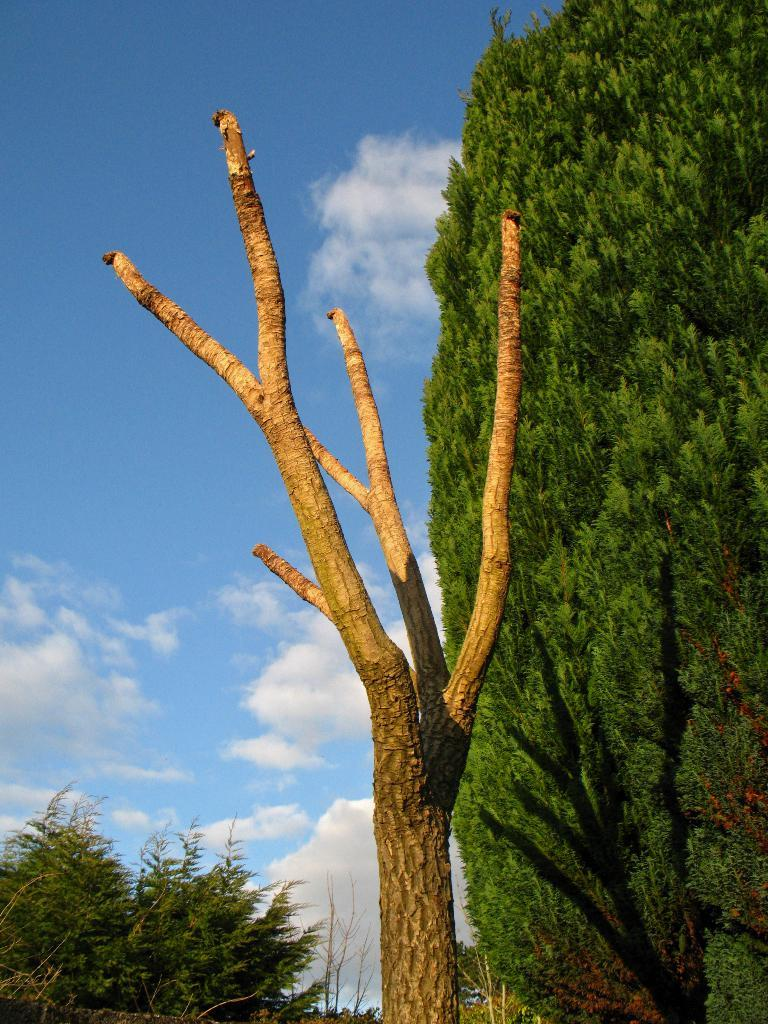What type of vegetation can be seen in the image? There are trees in the image. What is visible in the background of the image? The sky is visible in the background of the image. What can be observed in the sky? Clouds are present in the sky. What type of mask is being worn by the tree in the image? There is no mask present in the image, as it features trees and a sky with clouds. 